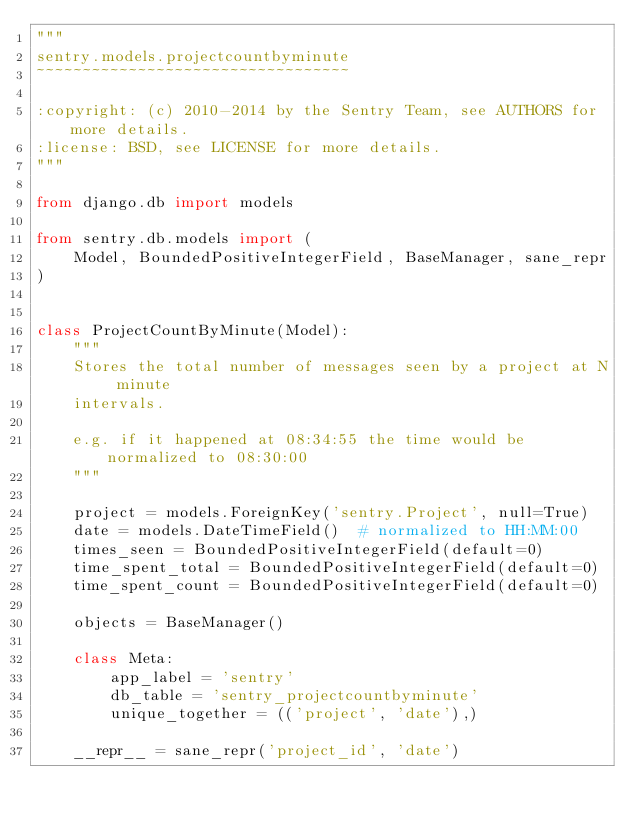<code> <loc_0><loc_0><loc_500><loc_500><_Python_>"""
sentry.models.projectcountbyminute
~~~~~~~~~~~~~~~~~~~~~~~~~~~~~~~~~~

:copyright: (c) 2010-2014 by the Sentry Team, see AUTHORS for more details.
:license: BSD, see LICENSE for more details.
"""

from django.db import models

from sentry.db.models import (
    Model, BoundedPositiveIntegerField, BaseManager, sane_repr
)


class ProjectCountByMinute(Model):
    """
    Stores the total number of messages seen by a project at N minute
    intervals.

    e.g. if it happened at 08:34:55 the time would be normalized to 08:30:00
    """

    project = models.ForeignKey('sentry.Project', null=True)
    date = models.DateTimeField()  # normalized to HH:MM:00
    times_seen = BoundedPositiveIntegerField(default=0)
    time_spent_total = BoundedPositiveIntegerField(default=0)
    time_spent_count = BoundedPositiveIntegerField(default=0)

    objects = BaseManager()

    class Meta:
        app_label = 'sentry'
        db_table = 'sentry_projectcountbyminute'
        unique_together = (('project', 'date'),)

    __repr__ = sane_repr('project_id', 'date')
</code> 